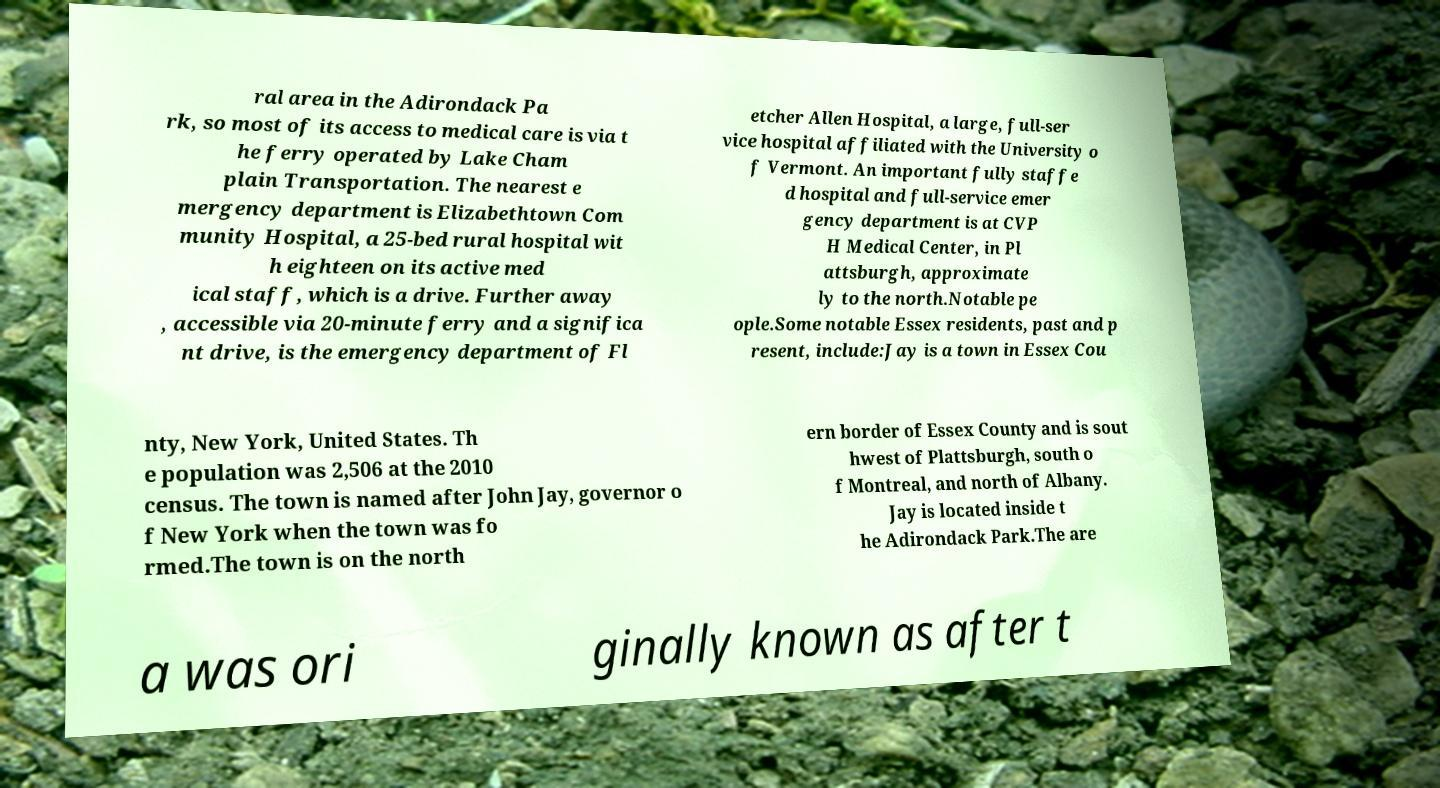Please read and relay the text visible in this image. What does it say? ral area in the Adirondack Pa rk, so most of its access to medical care is via t he ferry operated by Lake Cham plain Transportation. The nearest e mergency department is Elizabethtown Com munity Hospital, a 25-bed rural hospital wit h eighteen on its active med ical staff, which is a drive. Further away , accessible via 20-minute ferry and a significa nt drive, is the emergency department of Fl etcher Allen Hospital, a large, full-ser vice hospital affiliated with the University o f Vermont. An important fully staffe d hospital and full-service emer gency department is at CVP H Medical Center, in Pl attsburgh, approximate ly to the north.Notable pe ople.Some notable Essex residents, past and p resent, include:Jay is a town in Essex Cou nty, New York, United States. Th e population was 2,506 at the 2010 census. The town is named after John Jay, governor o f New York when the town was fo rmed.The town is on the north ern border of Essex County and is sout hwest of Plattsburgh, south o f Montreal, and north of Albany. Jay is located inside t he Adirondack Park.The are a was ori ginally known as after t 